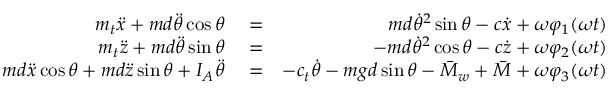Convert formula to latex. <formula><loc_0><loc_0><loc_500><loc_500>\begin{array} { r l r } { m _ { t } \ddot { x } + m d \ddot { \theta } \cos \theta } & = } & { m d \dot { \theta } ^ { 2 } \sin \theta - c \dot { x } + \omega \varphi _ { 1 } ( \omega t ) } \\ { m _ { t } \ddot { z } + m d \ddot { \theta } \sin \theta } & = } & { - m d \dot { \theta } ^ { 2 } \cos \theta - c \dot { z } + \omega \varphi _ { 2 } ( \omega t ) } \\ { m d \ddot { x } \cos \theta + m d \ddot { z } \sin \theta + I _ { A } \ddot { \theta } } & = } & { - c _ { t } \dot { \theta } - m g d \sin \theta - \bar { M } _ { w } + \bar { M } + \omega \varphi _ { 3 } ( \omega t ) } \end{array}</formula> 